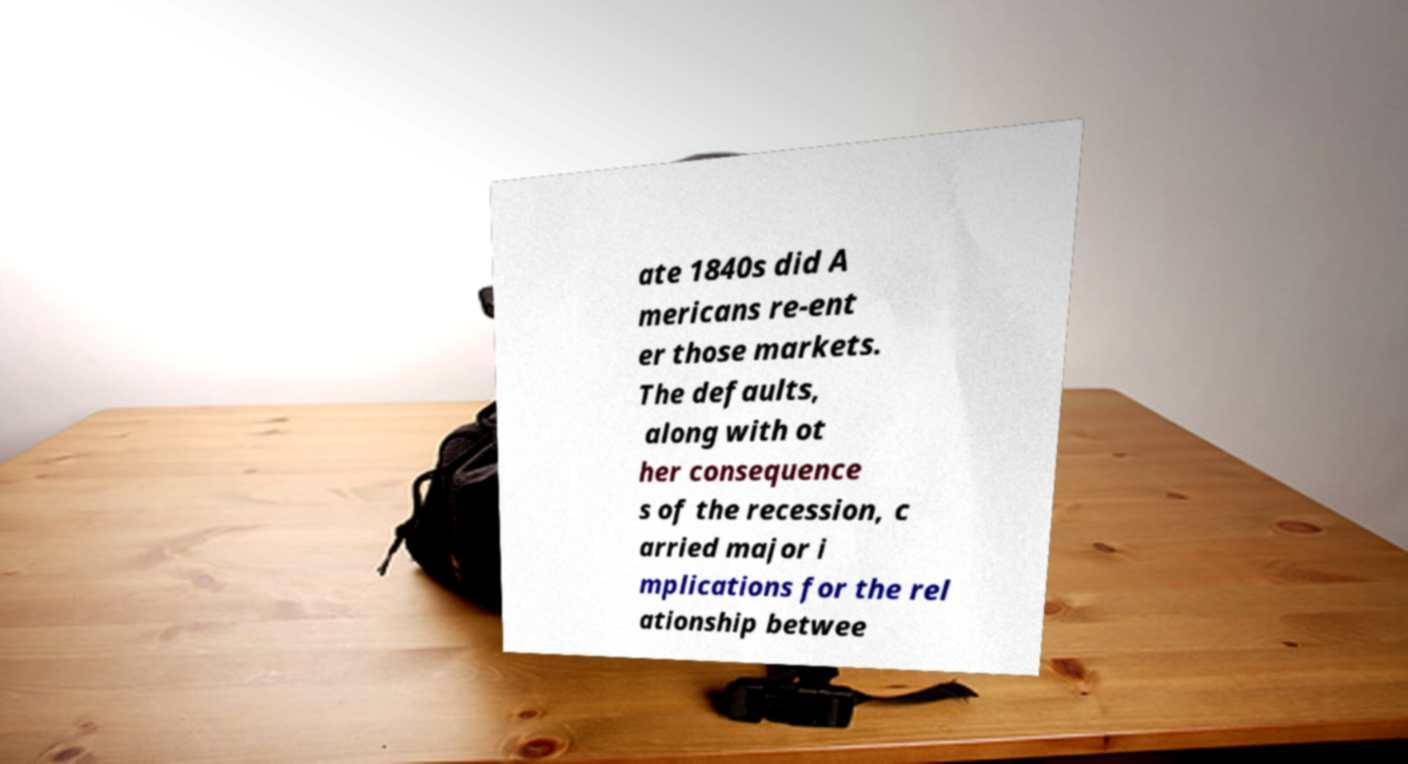I need the written content from this picture converted into text. Can you do that? ate 1840s did A mericans re-ent er those markets. The defaults, along with ot her consequence s of the recession, c arried major i mplications for the rel ationship betwee 